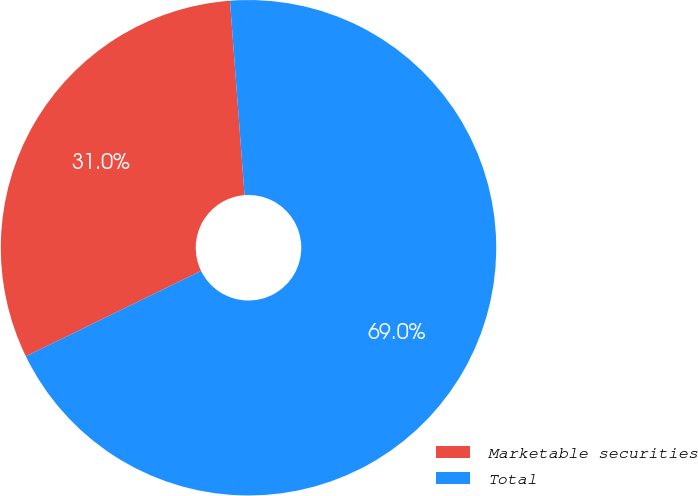<chart> <loc_0><loc_0><loc_500><loc_500><pie_chart><fcel>Marketable securities<fcel>Total<nl><fcel>31.03%<fcel>68.97%<nl></chart> 